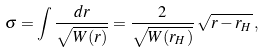<formula> <loc_0><loc_0><loc_500><loc_500>\sigma = \int \frac { d r } { \sqrt { W ( r ) } } = \frac { 2 } { \sqrt { W ( r _ { H } ) } } \, \sqrt { r - r _ { H } } \, ,</formula> 